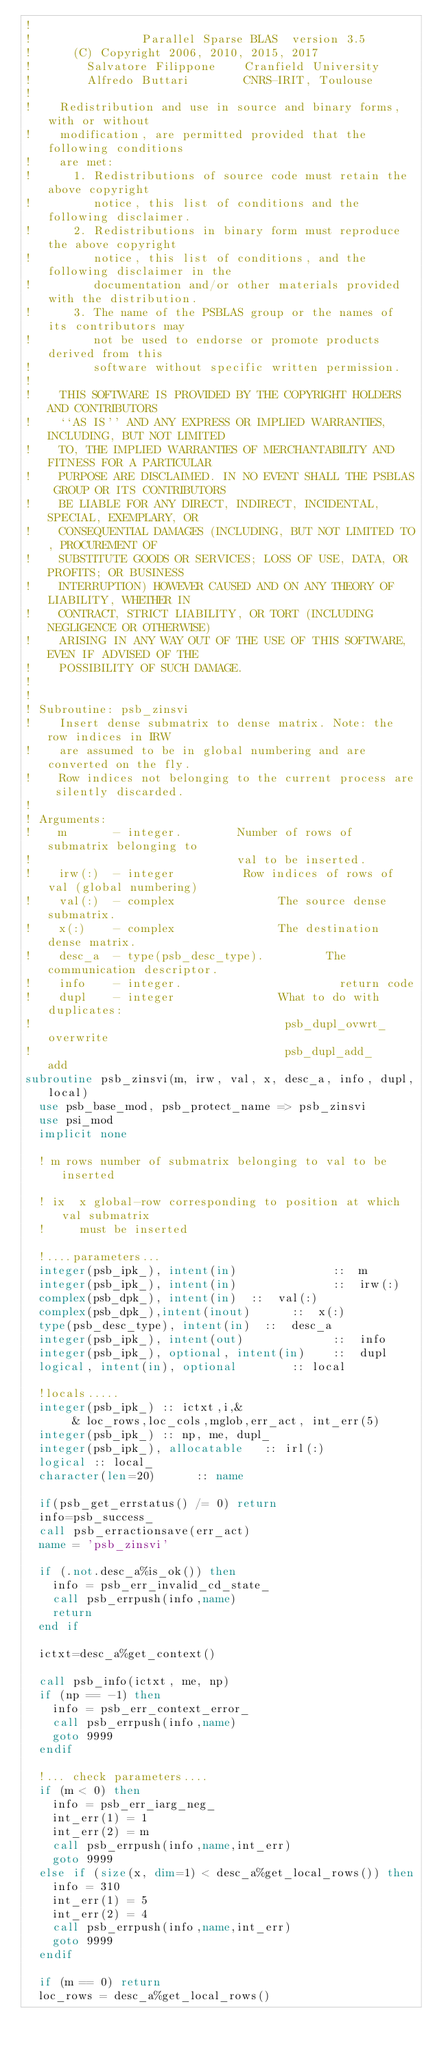Convert code to text. <code><loc_0><loc_0><loc_500><loc_500><_FORTRAN_>!   
!                Parallel Sparse BLAS  version 3.5
!      (C) Copyright 2006, 2010, 2015, 2017
!        Salvatore Filippone    Cranfield University
!        Alfredo Buttari        CNRS-IRIT, Toulouse
!   
!    Redistribution and use in source and binary forms, with or without
!    modification, are permitted provided that the following conditions
!    are met:
!      1. Redistributions of source code must retain the above copyright
!         notice, this list of conditions and the following disclaimer.
!      2. Redistributions in binary form must reproduce the above copyright
!         notice, this list of conditions, and the following disclaimer in the
!         documentation and/or other materials provided with the distribution.
!      3. The name of the PSBLAS group or the names of its contributors may
!         not be used to endorse or promote products derived from this
!         software without specific written permission.
!   
!    THIS SOFTWARE IS PROVIDED BY THE COPYRIGHT HOLDERS AND CONTRIBUTORS
!    ``AS IS'' AND ANY EXPRESS OR IMPLIED WARRANTIES, INCLUDING, BUT NOT LIMITED
!    TO, THE IMPLIED WARRANTIES OF MERCHANTABILITY AND FITNESS FOR A PARTICULAR
!    PURPOSE ARE DISCLAIMED. IN NO EVENT SHALL THE PSBLAS GROUP OR ITS CONTRIBUTORS
!    BE LIABLE FOR ANY DIRECT, INDIRECT, INCIDENTAL, SPECIAL, EXEMPLARY, OR
!    CONSEQUENTIAL DAMAGES (INCLUDING, BUT NOT LIMITED TO, PROCUREMENT OF
!    SUBSTITUTE GOODS OR SERVICES; LOSS OF USE, DATA, OR PROFITS; OR BUSINESS
!    INTERRUPTION) HOWEVER CAUSED AND ON ANY THEORY OF LIABILITY, WHETHER IN
!    CONTRACT, STRICT LIABILITY, OR TORT (INCLUDING NEGLIGENCE OR OTHERWISE)
!    ARISING IN ANY WAY OUT OF THE USE OF THIS SOFTWARE, EVEN IF ADVISED OF THE
!    POSSIBILITY OF SUCH DAMAGE.
!   
!    
! Subroutine: psb_zinsvi
!    Insert dense submatrix to dense matrix. Note: the row indices in IRW 
!    are assumed to be in global numbering and are converted on the fly. 
!    Row indices not belonging to the current process are silently discarded.
! 
! Arguments: 
!    m       - integer.        Number of rows of submatrix belonging to 
!                              val to be inserted.
!    irw(:)  - integer          Row indices of rows of val (global numbering)
!    val(:)  - complex               The source dense submatrix.  
!    x(:)    - complex               The destination dense matrix.  
!    desc_a  - type(psb_desc_type).         The communication descriptor.
!    info    - integer.                       return code
!    dupl    - integer               What to do with duplicates: 
!                                     psb_dupl_ovwrt_    overwrite
!                                     psb_dupl_add_      add         
subroutine psb_zinsvi(m, irw, val, x, desc_a, info, dupl,local)
  use psb_base_mod, psb_protect_name => psb_zinsvi
  use psi_mod
  implicit none

  ! m rows number of submatrix belonging to val to be inserted

  ! ix  x global-row corresponding to position at which val submatrix
  !     must be inserted

  !....parameters...
  integer(psb_ipk_), intent(in)              ::  m
  integer(psb_ipk_), intent(in)              ::  irw(:)
  complex(psb_dpk_), intent(in)  ::  val(:)
  complex(psb_dpk_),intent(inout)      ::  x(:)
  type(psb_desc_type), intent(in)  ::  desc_a
  integer(psb_ipk_), intent(out)             ::  info
  integer(psb_ipk_), optional, intent(in)    ::  dupl
  logical, intent(in), optional        :: local

  !locals.....
  integer(psb_ipk_) :: ictxt,i,&
       & loc_rows,loc_cols,mglob,err_act, int_err(5)
  integer(psb_ipk_) :: np, me, dupl_
  integer(psb_ipk_), allocatable   :: irl(:)
  logical :: local_
  character(len=20)      :: name

  if(psb_get_errstatus() /= 0) return 
  info=psb_success_
  call psb_erractionsave(err_act)
  name = 'psb_zinsvi'

  if (.not.desc_a%is_ok()) then
    info = psb_err_invalid_cd_state_
    call psb_errpush(info,name)
    return
  end if

  ictxt=desc_a%get_context()

  call psb_info(ictxt, me, np)
  if (np == -1) then
    info = psb_err_context_error_
    call psb_errpush(info,name)
    goto 9999
  endif

  !... check parameters....
  if (m < 0) then
    info = psb_err_iarg_neg_
    int_err(1) = 1
    int_err(2) = m
    call psb_errpush(info,name,int_err)
    goto 9999
  else if (size(x, dim=1) < desc_a%get_local_rows()) then
    info = 310
    int_err(1) = 5
    int_err(2) = 4
    call psb_errpush(info,name,int_err)
    goto 9999
  endif

  if (m == 0) return
  loc_rows = desc_a%get_local_rows()</code> 